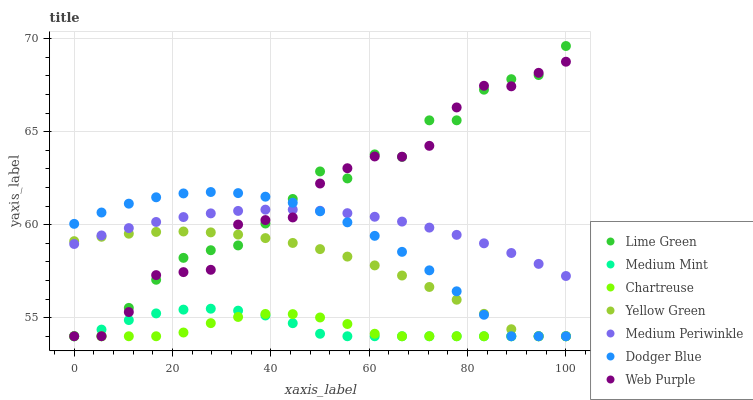Does Chartreuse have the minimum area under the curve?
Answer yes or no. Yes. Does Lime Green have the maximum area under the curve?
Answer yes or no. Yes. Does Yellow Green have the minimum area under the curve?
Answer yes or no. No. Does Yellow Green have the maximum area under the curve?
Answer yes or no. No. Is Medium Periwinkle the smoothest?
Answer yes or no. Yes. Is Lime Green the roughest?
Answer yes or no. Yes. Is Yellow Green the smoothest?
Answer yes or no. No. Is Yellow Green the roughest?
Answer yes or no. No. Does Medium Mint have the lowest value?
Answer yes or no. Yes. Does Medium Periwinkle have the lowest value?
Answer yes or no. No. Does Lime Green have the highest value?
Answer yes or no. Yes. Does Yellow Green have the highest value?
Answer yes or no. No. Is Chartreuse less than Medium Periwinkle?
Answer yes or no. Yes. Is Medium Periwinkle greater than Chartreuse?
Answer yes or no. Yes. Does Yellow Green intersect Dodger Blue?
Answer yes or no. Yes. Is Yellow Green less than Dodger Blue?
Answer yes or no. No. Is Yellow Green greater than Dodger Blue?
Answer yes or no. No. Does Chartreuse intersect Medium Periwinkle?
Answer yes or no. No. 